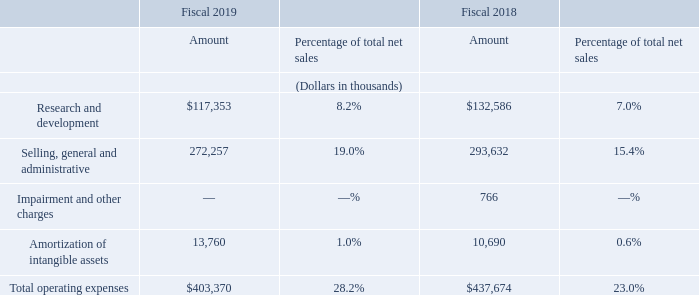Operating Expenses
The following table sets forth, for the periods indicated, the amount of operating expenses and their relative percentages of total net sales by the line items reflected in our consolidated statement of operations (dollars in thousands):
What was total operating expenses in 2019?
Answer scale should be: thousand. $403,370. What was  Amortization of intangible assets  in 2018?
Answer scale should be: thousand. 10,690. In which years was operating expenses calculated? 2019, 2018. In which year was Amortization of intangible assets a higher percentage of total net sales? 1.0%>0.6%
Answer: 2019. What was the change in the amount of Amortization of intangible assets in 2019 from 2018?
Answer scale should be: thousand. 13,760-10,690
Answer: 3070. What was the percentage change in the amount of Amortization of intangible assets in 2019 from 2018?
Answer scale should be: percent. (13,760-10,690)/10,690
Answer: 28.72. 